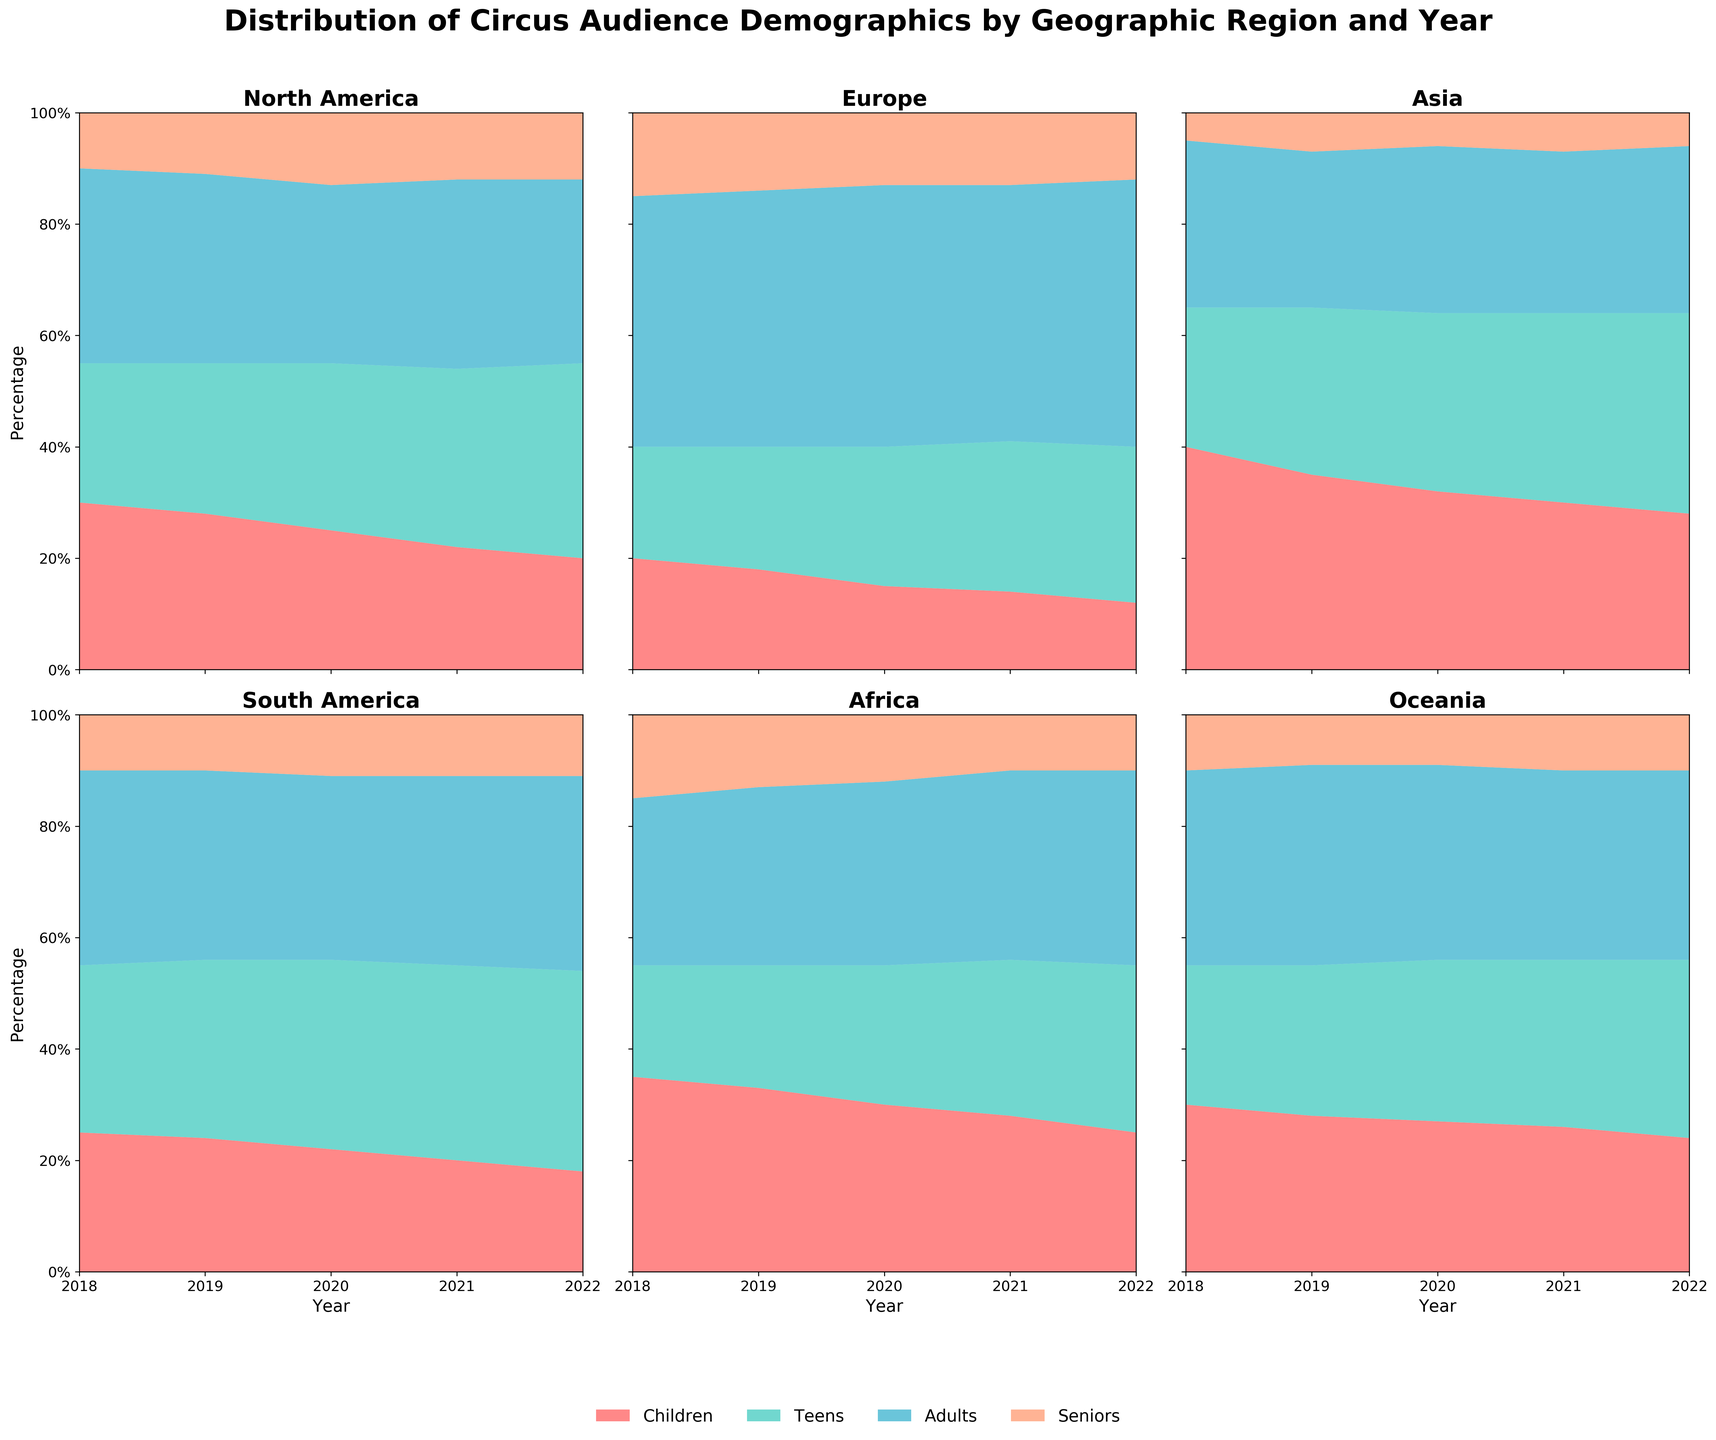What is the title of the figure? The title is displayed at the top of the figure.
Answer: Distribution of Circus Audience Demographics by Geographic Region and Year How many geographic regions are listed in the figure? The figure has six subplots, one for each geographic region, indicating the number of regions.
Answer: 6 Which age group had the highest percentage in North America in 2022? By observing the 100% stacked area chart for North America in 2022, the "Teens" section has the largest area.
Answer: Teens What is the trend of the Children percentage in Europe from 2018 to 2022? Check the areas representing Children in the Europe subplot from left (2018) to right (2022). The area decreases over the years.
Answer: Decreasing In which region and year did the audience percentage for Seniors appear to be the lowest? Compare the lowest sections representing Seniors across all regions and years.
Answer: Asia, 2018 How does the percentage of Adults in Asia in 2022 compare with that in 2018? Look at the Adults areas in Asia for both years. The area is larger in 2022 compared to 2018.
Answer: Higher in 2022 What is the overall trend for Teens in South America from 2018 to 2022? Observe the Teen category in the South America subplot across the years. The area increases over time.
Answer: Increasing Across all regions, which age group consistently held the largest percentage share? Check the largest area within each subplot for every region. Adults usually hold the largest share.
Answer: Adults Which two age groups see a consistent increase in their share percentage in North America from 2018 to 2022? For North America, observe the trends of the areas for each age group. Teens and Seniors show an increasing trend.
Answer: Teens and Seniors In Africa, what percentage does the Children's group approximately occupy in 2020? Look at the 2020 section for Africa and estimate the percentage of the Children part. It's close to 30%.
Answer: 30% 